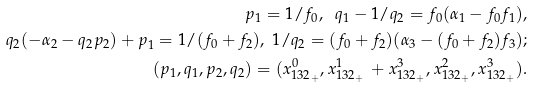Convert formula to latex. <formula><loc_0><loc_0><loc_500><loc_500>p _ { 1 } = 1 / f _ { 0 } , \ q _ { 1 } - 1 / q _ { 2 } = f _ { 0 } ( \alpha _ { 1 } - f _ { 0 } f _ { 1 } ) , \\ q _ { 2 } ( - \alpha _ { 2 } - q _ { 2 } p _ { 2 } ) + p _ { 1 } = 1 / ( f _ { 0 } + f _ { 2 } ) , \ 1 / q _ { 2 } = ( f _ { 0 } + f _ { 2 } ) ( \alpha _ { 3 } - ( f _ { 0 } + f _ { 2 } ) f _ { 3 } ) ; \\ ( p _ { 1 } , q _ { 1 } , p _ { 2 } , q _ { 2 } ) = ( x _ { 1 3 2 _ { + } } ^ { 0 } , x _ { 1 3 2 _ { + } } ^ { 1 } \, + x _ { 1 3 2 _ { + } } ^ { 3 } , x _ { 1 3 2 _ { + } } ^ { 2 } , x _ { 1 3 2 _ { + } } ^ { 3 } ) .</formula> 